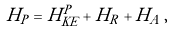Convert formula to latex. <formula><loc_0><loc_0><loc_500><loc_500>H _ { P } = H ^ { P } _ { K E } + H _ { R } + H _ { A } \, ,</formula> 